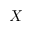Convert formula to latex. <formula><loc_0><loc_0><loc_500><loc_500>X</formula> 